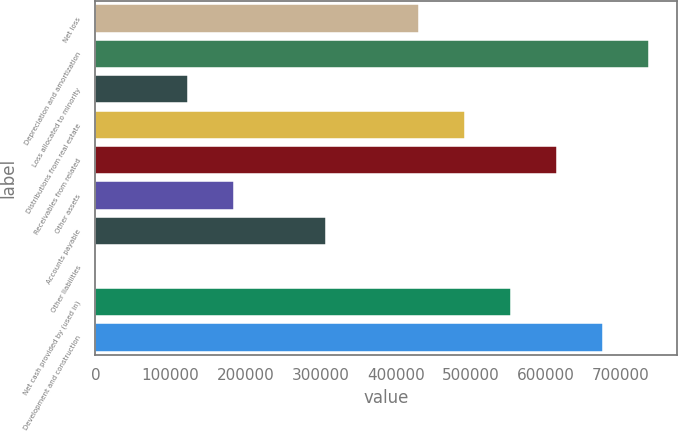<chart> <loc_0><loc_0><loc_500><loc_500><bar_chart><fcel>Net loss<fcel>Depreciation and amortization<fcel>Loss allocated to minority<fcel>Distributions from real estate<fcel>Receivables from related<fcel>Other assets<fcel>Accounts payable<fcel>Other liabilities<fcel>Net cash provided by (used in)<fcel>Development and construction<nl><fcel>430468<fcel>737745<fcel>123191<fcel>491923<fcel>614834<fcel>184646<fcel>307557<fcel>280<fcel>553379<fcel>676289<nl></chart> 